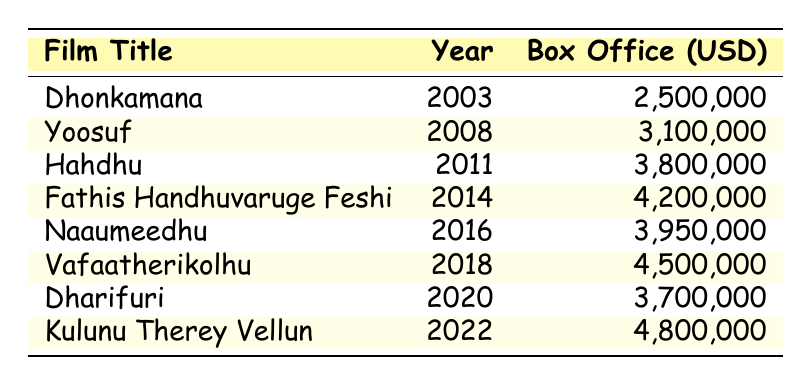What is the title of the film that had the highest box office earnings? To find the title of the film with the highest earnings, we can look through the box office column and identify the maximum value. The highest value is 4,800,000, which corresponds to the film "Kulunu Therey Vellun."
Answer: Kulunu Therey Vellun In which year did the film "Vafaatherikolhu" release? The release year of a film can be found directly in the table beside its title. For "Vafaatherikolhu," the year is listed as 2018.
Answer: 2018 What is the total box office earnings of all films starring Mohamed Waheed? We need to sum the box office earnings of all films listed. The earnings are: 2,500,000 + 3,100,000 + 3,800,000 + 4,200,000 + 3,950,000 + 4,500,000 + 3,700,000 + 4,800,000, which totals to 30,550,000.
Answer: 30,550,000 How much more did "Fathis Handhuvaruge Feshi" earn compared to "Dharifuri"? To determine the difference, we subtract the earnings of "Dharifuri" (3,700,000) from "Fathis Handhuvaruge Feshi" (4,200,000). So, 4,200,000 - 3,700,000 equals 500,000.
Answer: 500,000 What is the average box office earnings of the films listed? To calculate the average, sum all the box office earnings (30,550,000) and divide by the number of films (8). Thus, 30,550,000 / 8 equals 3,818,750.
Answer: 3,818,750 Did any film have box office earnings that were below 3 million? We can scan the box office column to see if any value is less than 3,000,000. The lowest earnings in the table is 2,500,000, which is below 3 million.
Answer: Yes Which film released in the years 2016 to 2020 had the lowest box office earnings? We need to compare the earnings of films from the years 2016 (3,950,000), 2018 (4,500,000), and 2020 (3,700,000). The lowest among these is "Dharifuri," with earnings of 3,700,000.
Answer: Dharifuri 